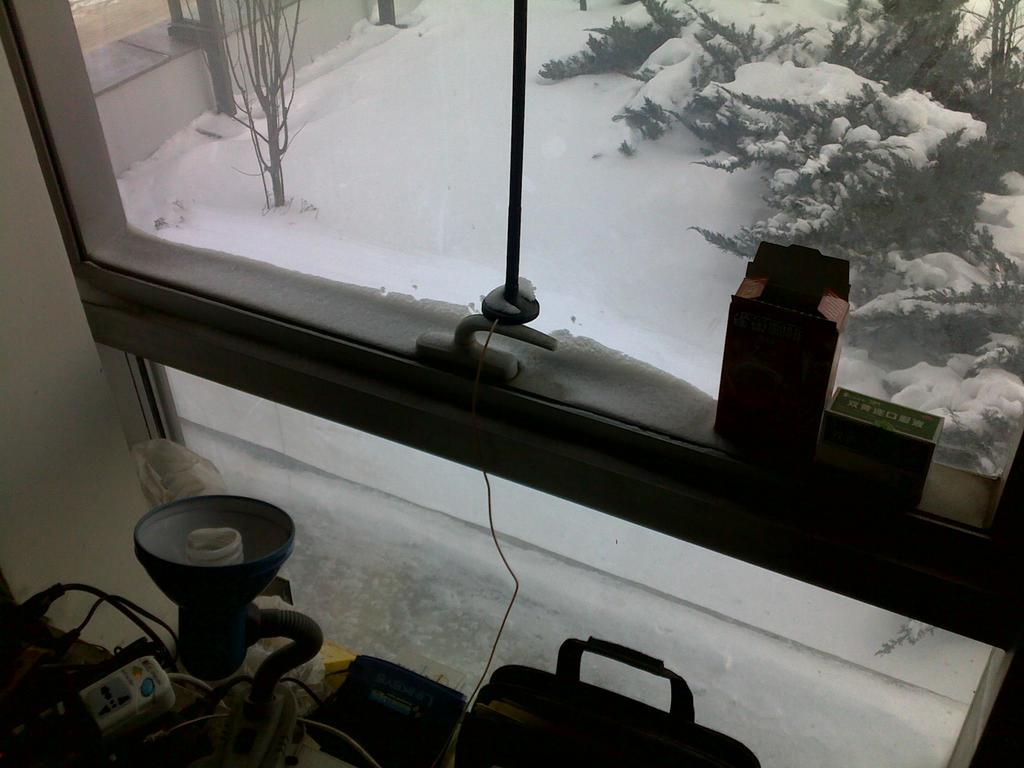Where was the picture taken from? The picture was taken from a house. What can be seen in the foreground of the picture? In the foreground, there are cables, bags, boxes, and a window. What is visible outside the window? Outside the window, there are trees, a wall, and snow. What type of pancake is being served on the tramp outside the window? There is no tramp or pancake present in the image. The image shows a view outside the window with trees, a wall, and snow, but no tramp or pancake. 